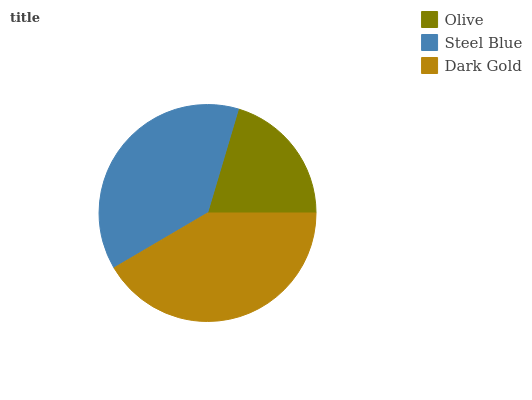Is Olive the minimum?
Answer yes or no. Yes. Is Dark Gold the maximum?
Answer yes or no. Yes. Is Steel Blue the minimum?
Answer yes or no. No. Is Steel Blue the maximum?
Answer yes or no. No. Is Steel Blue greater than Olive?
Answer yes or no. Yes. Is Olive less than Steel Blue?
Answer yes or no. Yes. Is Olive greater than Steel Blue?
Answer yes or no. No. Is Steel Blue less than Olive?
Answer yes or no. No. Is Steel Blue the high median?
Answer yes or no. Yes. Is Steel Blue the low median?
Answer yes or no. Yes. Is Olive the high median?
Answer yes or no. No. Is Dark Gold the low median?
Answer yes or no. No. 